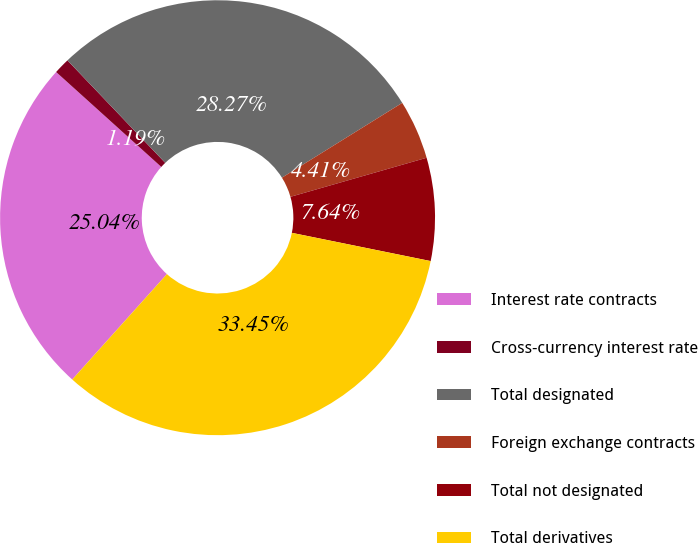<chart> <loc_0><loc_0><loc_500><loc_500><pie_chart><fcel>Interest rate contracts<fcel>Cross-currency interest rate<fcel>Total designated<fcel>Foreign exchange contracts<fcel>Total not designated<fcel>Total derivatives<nl><fcel>25.04%<fcel>1.19%<fcel>28.27%<fcel>4.41%<fcel>7.64%<fcel>33.45%<nl></chart> 